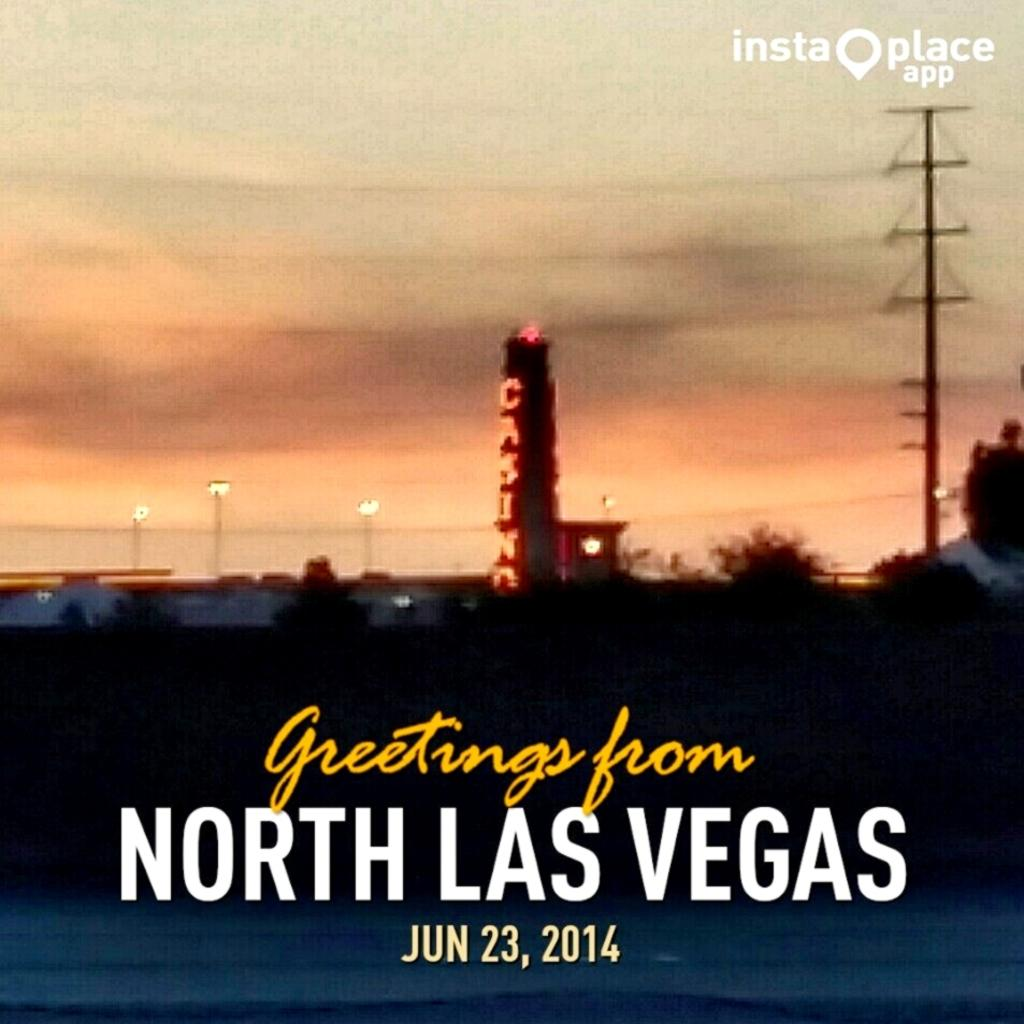<image>
Offer a succinct explanation of the picture presented. Photo with sunset and Greetings from North Las Vegas 